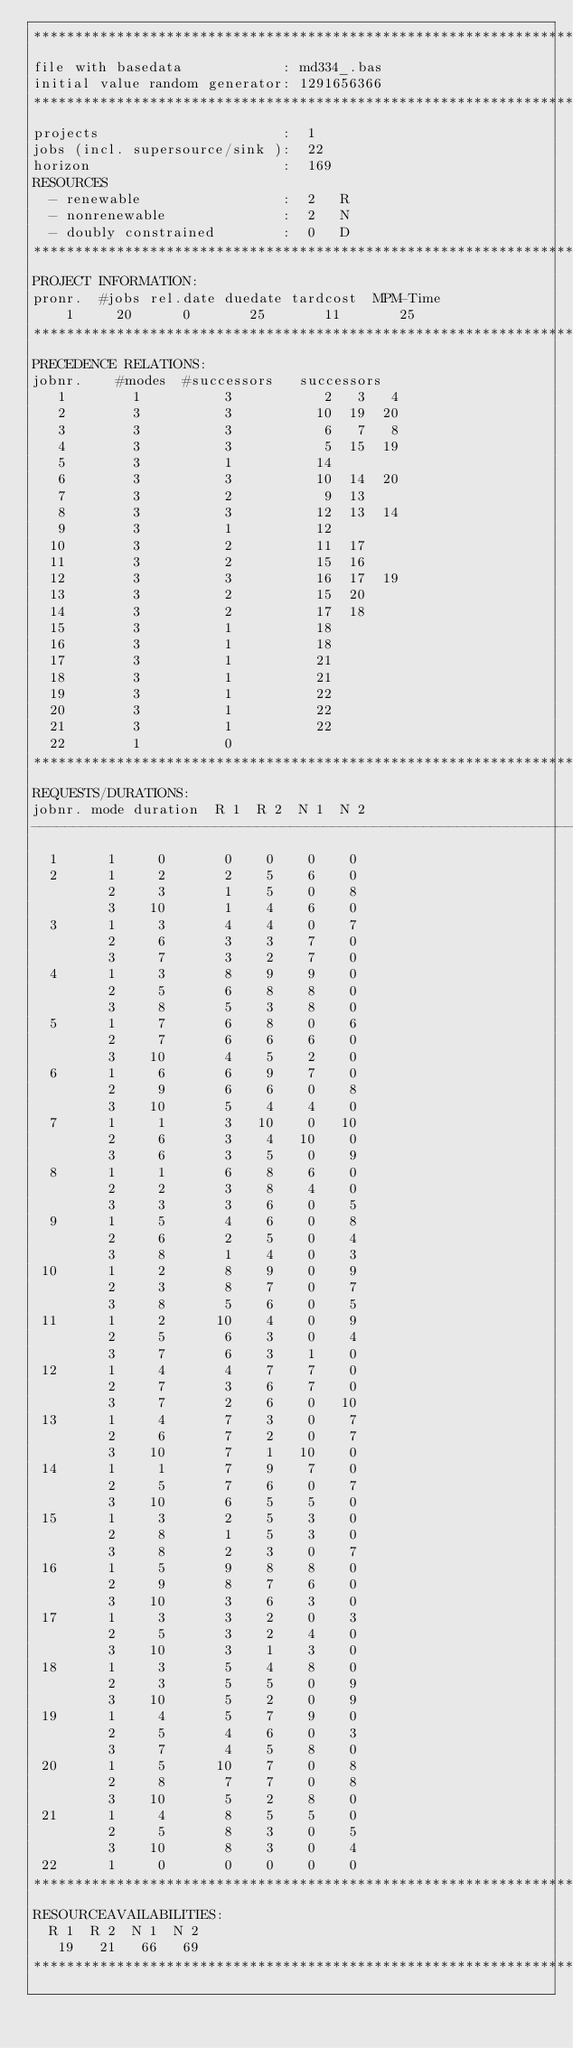<code> <loc_0><loc_0><loc_500><loc_500><_ObjectiveC_>************************************************************************
file with basedata            : md334_.bas
initial value random generator: 1291656366
************************************************************************
projects                      :  1
jobs (incl. supersource/sink ):  22
horizon                       :  169
RESOURCES
  - renewable                 :  2   R
  - nonrenewable              :  2   N
  - doubly constrained        :  0   D
************************************************************************
PROJECT INFORMATION:
pronr.  #jobs rel.date duedate tardcost  MPM-Time
    1     20      0       25       11       25
************************************************************************
PRECEDENCE RELATIONS:
jobnr.    #modes  #successors   successors
   1        1          3           2   3   4
   2        3          3          10  19  20
   3        3          3           6   7   8
   4        3          3           5  15  19
   5        3          1          14
   6        3          3          10  14  20
   7        3          2           9  13
   8        3          3          12  13  14
   9        3          1          12
  10        3          2          11  17
  11        3          2          15  16
  12        3          3          16  17  19
  13        3          2          15  20
  14        3          2          17  18
  15        3          1          18
  16        3          1          18
  17        3          1          21
  18        3          1          21
  19        3          1          22
  20        3          1          22
  21        3          1          22
  22        1          0        
************************************************************************
REQUESTS/DURATIONS:
jobnr. mode duration  R 1  R 2  N 1  N 2
------------------------------------------------------------------------
  1      1     0       0    0    0    0
  2      1     2       2    5    6    0
         2     3       1    5    0    8
         3    10       1    4    6    0
  3      1     3       4    4    0    7
         2     6       3    3    7    0
         3     7       3    2    7    0
  4      1     3       8    9    9    0
         2     5       6    8    8    0
         3     8       5    3    8    0
  5      1     7       6    8    0    6
         2     7       6    6    6    0
         3    10       4    5    2    0
  6      1     6       6    9    7    0
         2     9       6    6    0    8
         3    10       5    4    4    0
  7      1     1       3   10    0   10
         2     6       3    4   10    0
         3     6       3    5    0    9
  8      1     1       6    8    6    0
         2     2       3    8    4    0
         3     3       3    6    0    5
  9      1     5       4    6    0    8
         2     6       2    5    0    4
         3     8       1    4    0    3
 10      1     2       8    9    0    9
         2     3       8    7    0    7
         3     8       5    6    0    5
 11      1     2      10    4    0    9
         2     5       6    3    0    4
         3     7       6    3    1    0
 12      1     4       4    7    7    0
         2     7       3    6    7    0
         3     7       2    6    0   10
 13      1     4       7    3    0    7
         2     6       7    2    0    7
         3    10       7    1   10    0
 14      1     1       7    9    7    0
         2     5       7    6    0    7
         3    10       6    5    5    0
 15      1     3       2    5    3    0
         2     8       1    5    3    0
         3     8       2    3    0    7
 16      1     5       9    8    8    0
         2     9       8    7    6    0
         3    10       3    6    3    0
 17      1     3       3    2    0    3
         2     5       3    2    4    0
         3    10       3    1    3    0
 18      1     3       5    4    8    0
         2     3       5    5    0    9
         3    10       5    2    0    9
 19      1     4       5    7    9    0
         2     5       4    6    0    3
         3     7       4    5    8    0
 20      1     5      10    7    0    8
         2     8       7    7    0    8
         3    10       5    2    8    0
 21      1     4       8    5    5    0
         2     5       8    3    0    5
         3    10       8    3    0    4
 22      1     0       0    0    0    0
************************************************************************
RESOURCEAVAILABILITIES:
  R 1  R 2  N 1  N 2
   19   21   66   69
************************************************************************
</code> 